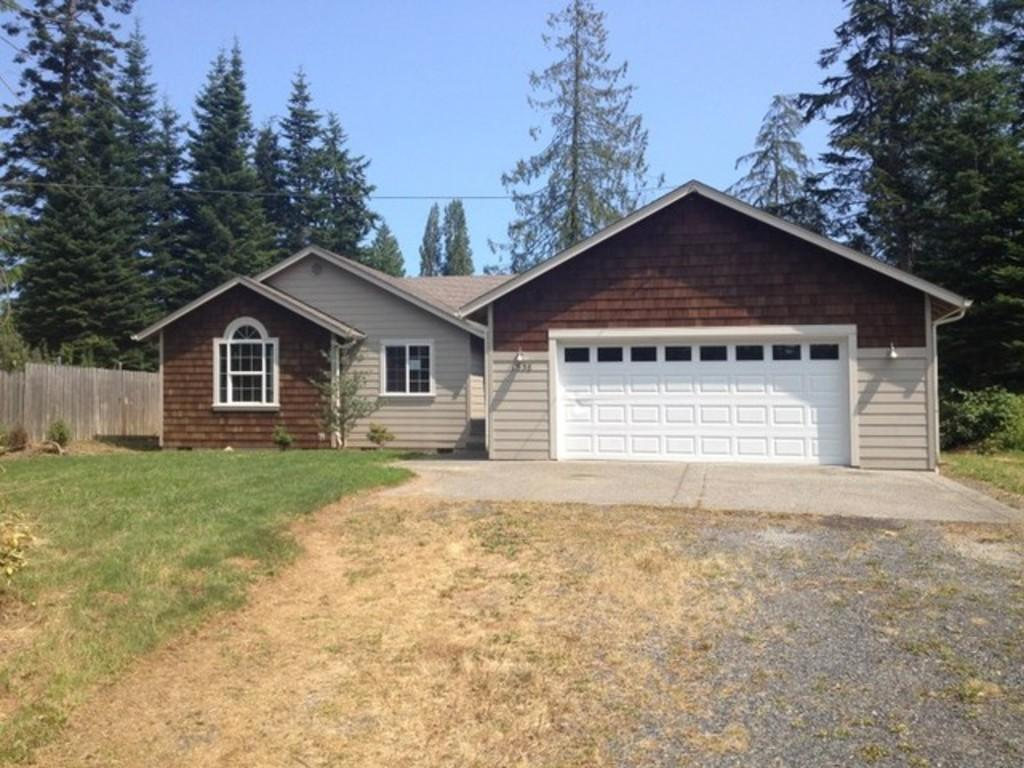What type of structures are present in the image? There are sheds in the image. What type of vegetation can be seen in the image? There are trees and plants in the image. What type of barrier is present in the image? There is a fence in the image. What part of the natural environment is visible in the image? The sky is visible at the top of the image, and the ground is visible at the bottom of the image. What type of stew is being cooked by the governor in the image? There is no governor or stew present in the image. Can you tell me how many friends are visible in the image? There are no friends present in the image. 